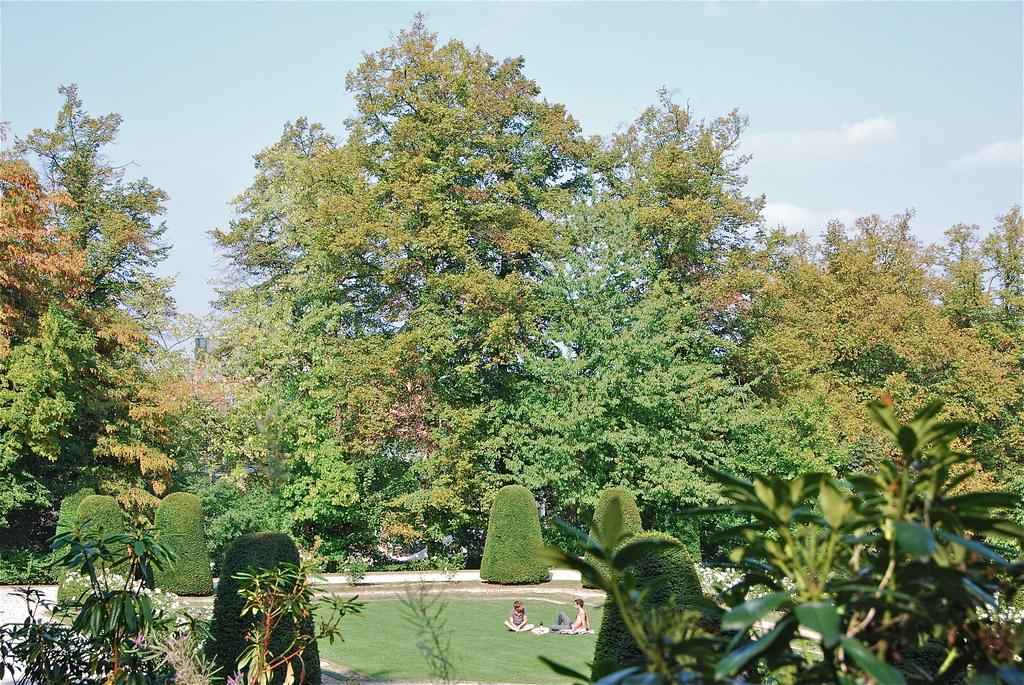What are the men in the image doing? The men in the image are sitting on the ground. What type of vegetation can be seen in the image? There are plants, bushes, and trees in the image. What is visible in the background of the image? The sky is visible in the image, and clouds are present in the sky. What emotion can be seen on the men's faces as they read the fifth disgusting book in the image? There is no mention of reading, disgust, or a fifth book in the image. The men are simply sitting on the ground, and the image does not depict any books or emotions. 